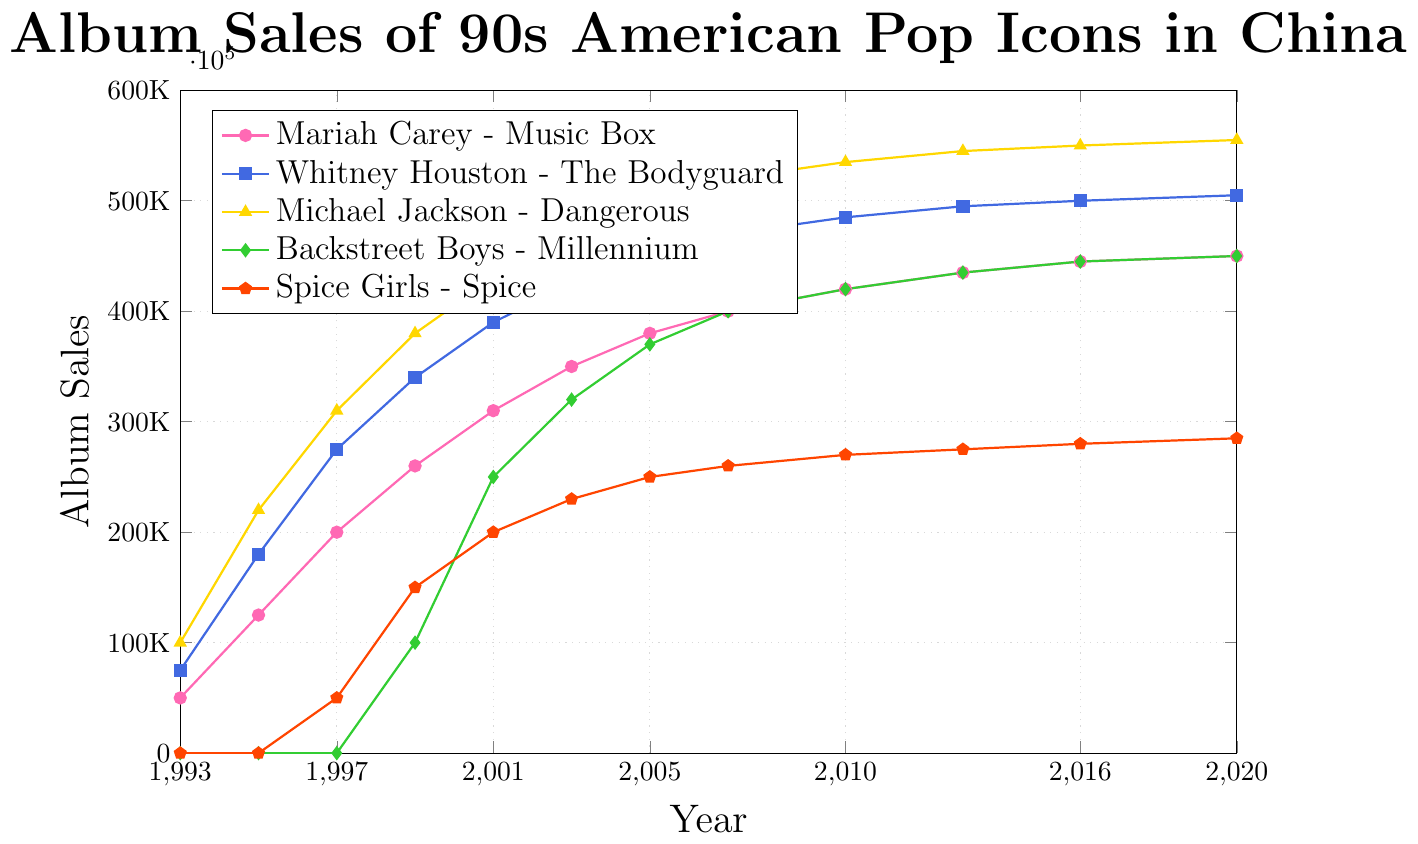Which album had the highest sales in 2020? The lines representing the album sales show the data for 2020. Michael Jackson's "Dangerous" had the highest point at that year.
Answer: Michael Jackson - Dangerous How many years did it take for "Spice Girls - Spice" to reach 200,000 in sales? The "Spice Girls - Spice" line starts in 1997 and reaches 200,000 by 2001. Subtract the starting year from the year it reached the milestone: 2001 - 1997.
Answer: 4 years Which album showed the greatest increase in sales between 1993 and 1995? By looking at the vertical distance on the y-axis between the points for 1993 and 1995 for each line, Michael Jackson's "Dangerous" shows the greatest increase from 100,000 to 220,000 (a difference of 120,000).
Answer: Michael Jackson - Dangerous How often between 2003 and 2020 did "Whitney Houston - The Bodyguard" album sales increase? Checking each year for "Whitney Houston - The Bodyguard," sales increased between 2005, 2007, and 2010.
Answer: 3 times By how many sales did "Backstreet Boys - Millennium" increase from its release in 1999 to 2007? Check the values for 1999 and 2007. For the "Backstreet Boys - Millennium," sales increased from 100,000 to 400,000. The difference is 400,000 - 100,000.
Answer: 300,000 Compare the album sales of "Mariah Carey - Music Box" and "Whitney Houston - The Bodyguard" in 2005. Which was higher and by how much? In 2005, "Mariah Carey - Music Box" had 380,000 sales, and "Whitney Houston - The Bodyguard" had 450,000 sales. Subtract the former from the latter: 450,000 - 380,000.
Answer: Whitney Houston - The Bodyguard by 70,000 What is the combined sales of "Michael Jackson - Dangerous" and "Spice Girls - Spice" in 1999? Add the sales number for "Michael Jackson - Dangerous" and "Spice Girls - Spice" in 1999. (380,000 + 150,000)
Answer: 530,000 Which album had the slowest growth rate from 2005 to 2020? Evaluating the slopes of the lines from 2005 to 2020, "Spice Girls - Spice" increased only by 35,000 (from 250,000 to 285,000) over this period, showing the slowest growth.
Answer: Spice Girls - Spice In what year did "Backstreet Boys - Millennium" surpass 300,000 in sales? By checking the points where the "Backstreet Boys - Millennium" line crosses above 300,000, it occurs in 2003.
Answer: 2003 